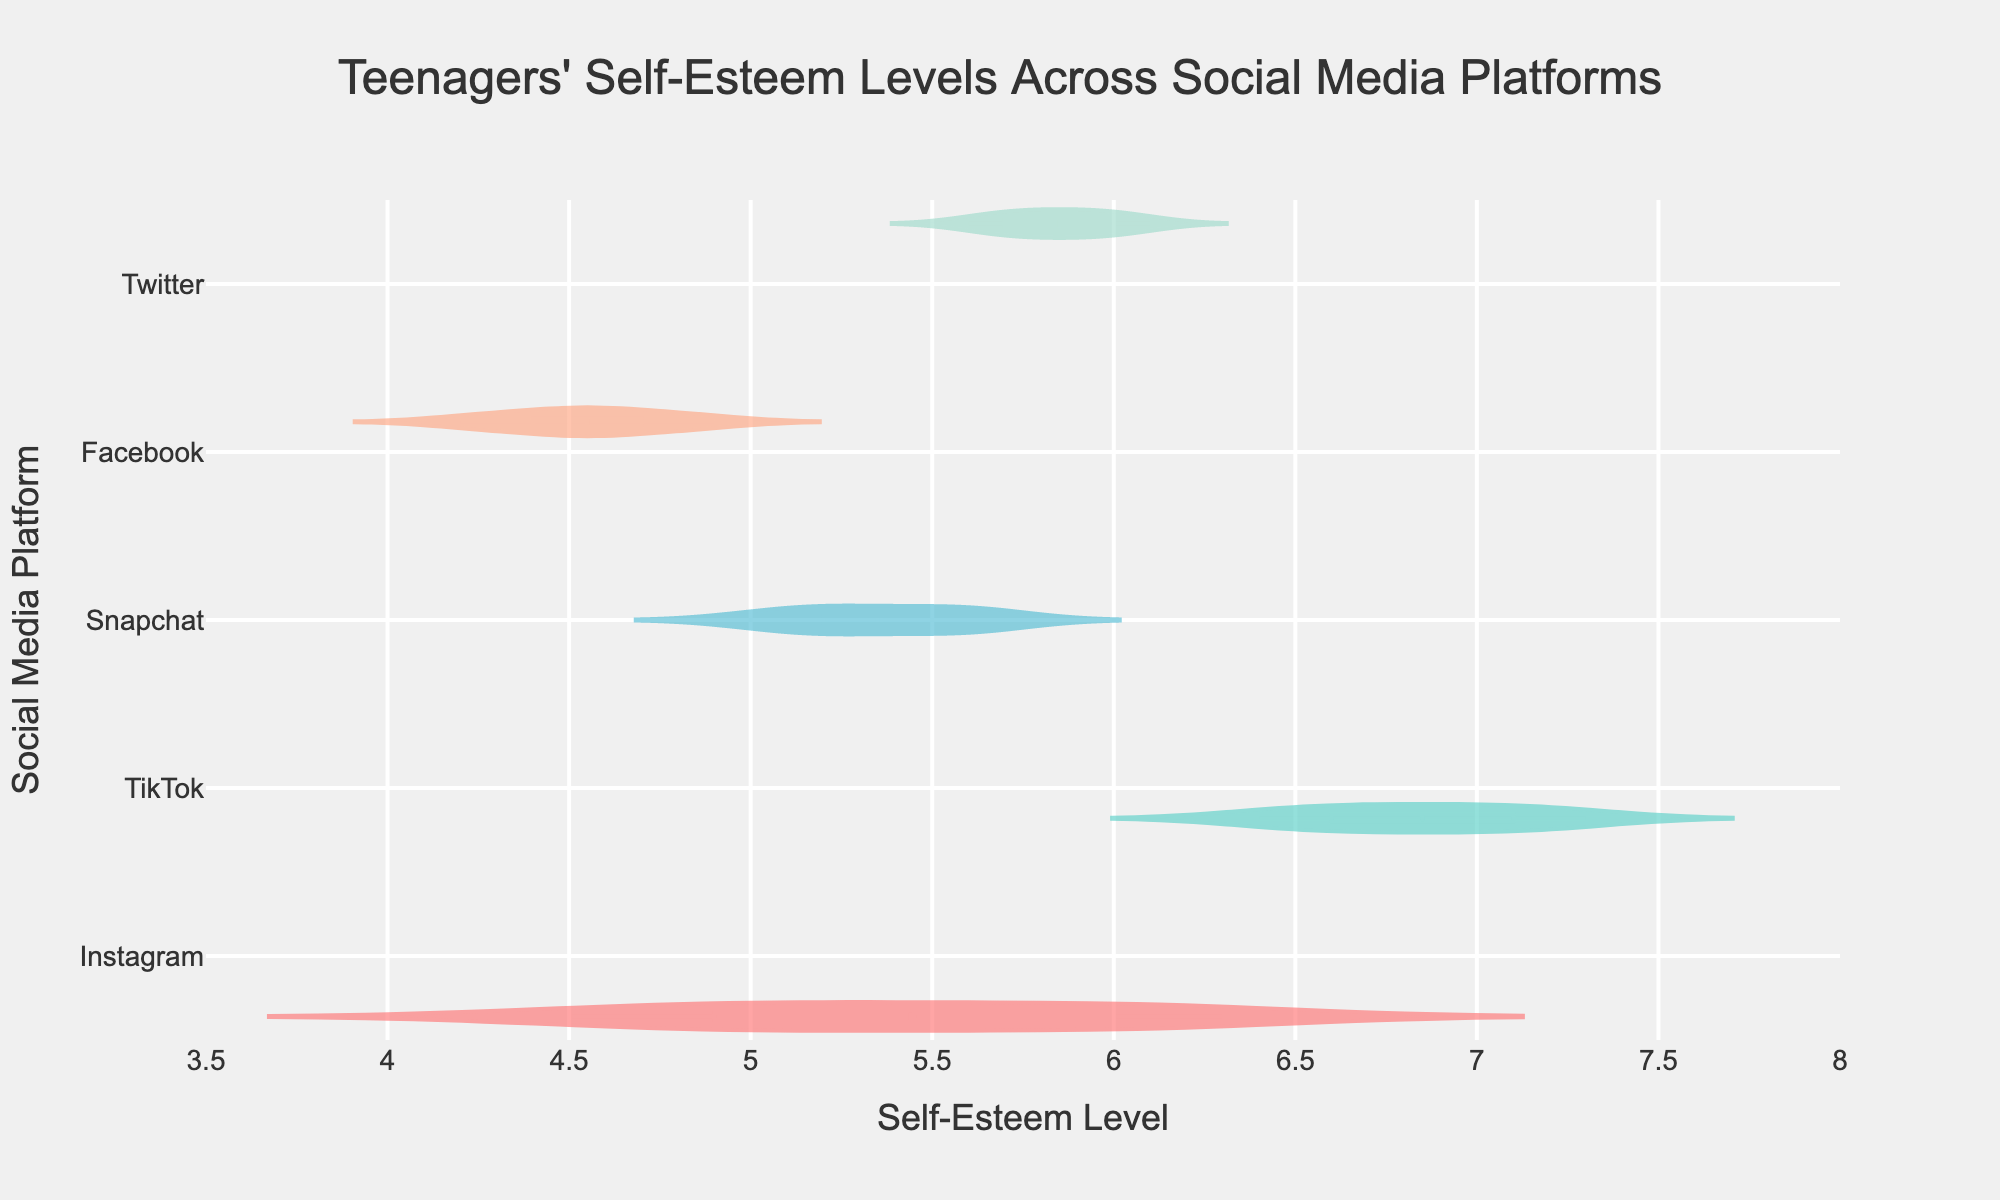How many different social media platforms are represented in the figure? The figure displays data for five social media platforms: Instagram, TikTok, Snapchat, Facebook, and Twitter. You can identify this by counting the unique platforms shown on the y-axis.
Answer: 5 What is the title of the figure? The title is displayed at the top of the figure. It serves to explain what the figure represents, which is showing the levels of self-esteem for teenagers across different social media platforms.
Answer: "Teenagers' Self-Esteem Levels Across Social Media Platforms" Which social media platform generally shows the highest self-esteem levels among teenagers? By examining the violin plots, TikTok has the highest median self-esteem level, indicated by the position of the mean line in the plot.
Answer: TikTok Which social media platform has the lowest range of self-esteem levels? Looking at the spread of the violin plots, Facebook has the smallest range of self-esteem levels. This is visually identifiable by the narrow distribution of data points.
Answer: Facebook What is the mean self-esteem level for Snapchat? The mean self-esteem level for Snapchat can be identified by the mean line within the Snapchat violin plot, which is indicated by a horizontal line inside the distribution.
Answer: Approximately 5.4 How does the range of self-esteem levels for Twitter compare to Instagram? The range for Twitter (approximately 5.6 to 6.1) is smaller than that for Instagram (approximately 4.5 to 6.3). This comparison is done by visually examining the spread (width) of the violin plots.
Answer: Twitter has a smaller range What is the median self-esteem level for Facebook? The median is indicated by the solid line in the violin plot for Facebook. By inspecting the Facebook plot, this line is at the level of about 4.5.
Answer: 4.5 Which platform shows the most variability in self-esteem levels? Variability can be assessed by looking at the spread of the data in the violin plots. Instagram shows the most variability as it has a wider spread of data points compared to other platforms.
Answer: Instagram Is there an overlap in self-esteem levels between Snapchat and Twitter? To check for overlap, we look at the spread of the violin plots for Snapchat and Twitter. Both plots overlap in the range of approximately 5.6 to 5.9.
Answer: Yes 